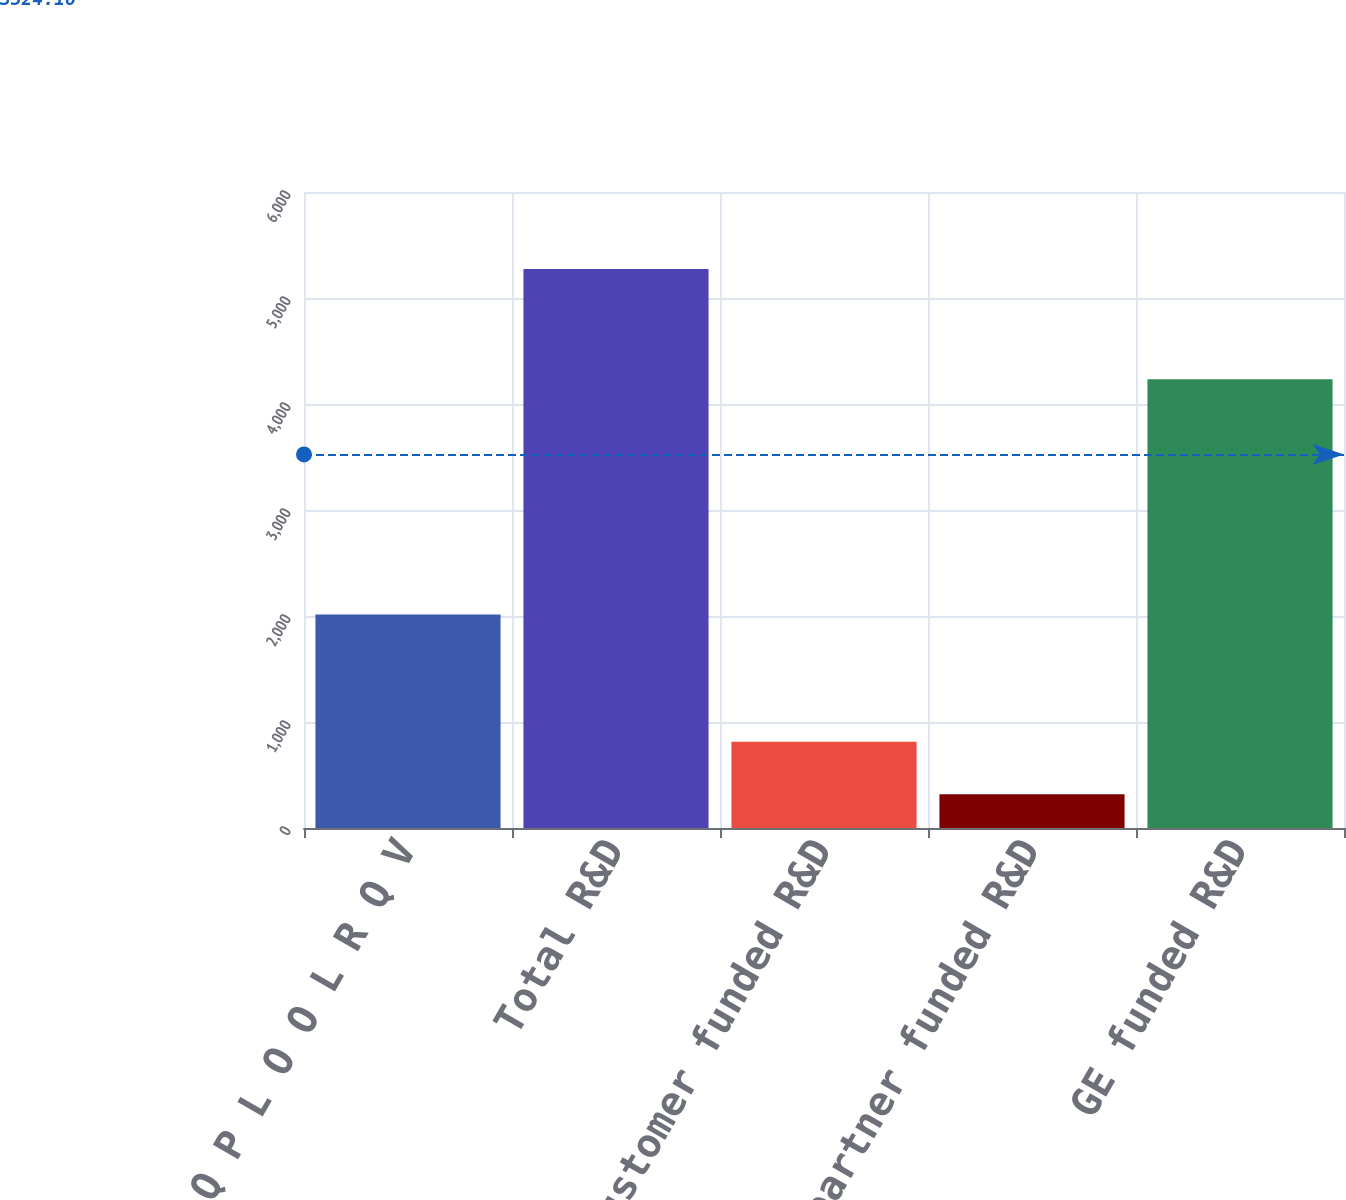<chart> <loc_0><loc_0><loc_500><loc_500><bar_chart><fcel>Q P L O O L R Q V<fcel>Total R&D<fcel>Less customer funded R&D<fcel>Less partner funded R&D<fcel>GE funded R&D<nl><fcel>2014<fcel>5273<fcel>814.4<fcel>319<fcel>4233<nl></chart> 